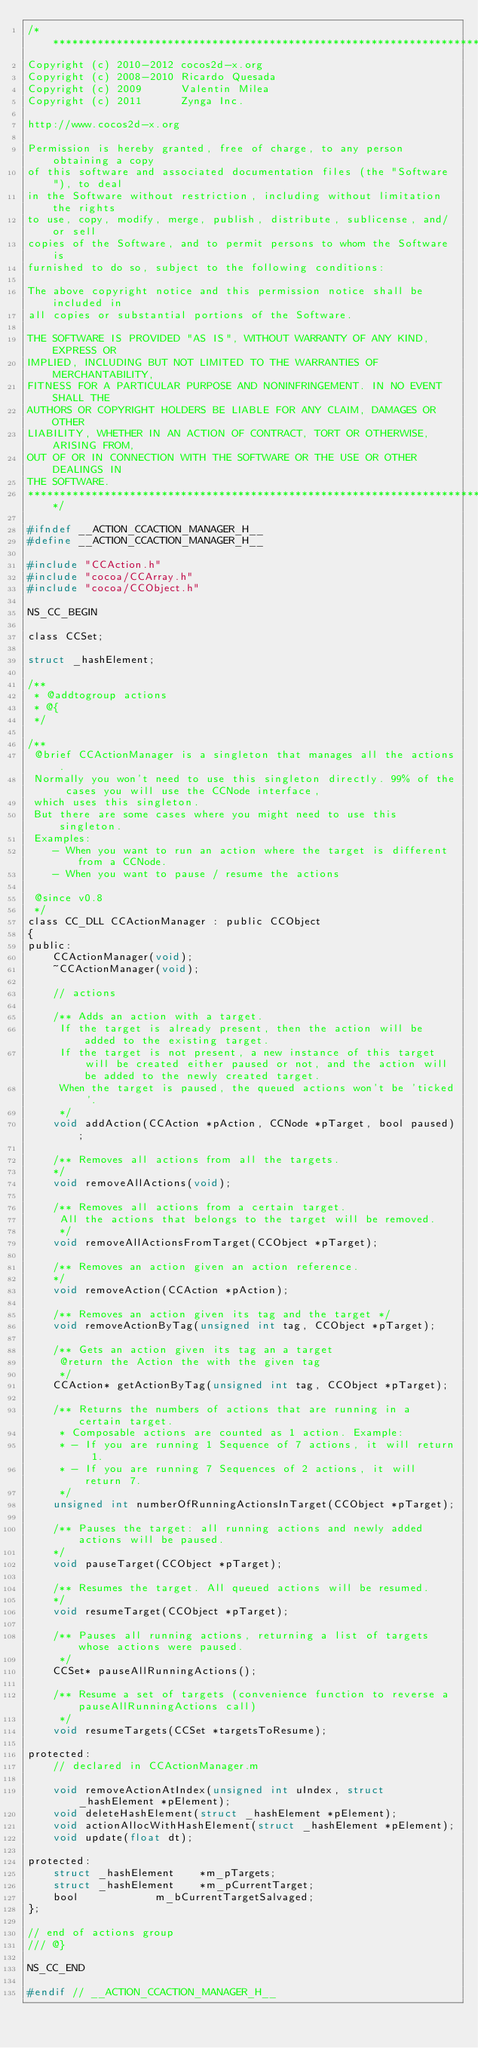Convert code to text. <code><loc_0><loc_0><loc_500><loc_500><_C_>/****************************************************************************
Copyright (c) 2010-2012 cocos2d-x.org
Copyright (c) 2008-2010 Ricardo Quesada
Copyright (c) 2009      Valentin Milea
Copyright (c) 2011      Zynga Inc.

http://www.cocos2d-x.org

Permission is hereby granted, free of charge, to any person obtaining a copy
of this software and associated documentation files (the "Software"), to deal
in the Software without restriction, including without limitation the rights
to use, copy, modify, merge, publish, distribute, sublicense, and/or sell
copies of the Software, and to permit persons to whom the Software is
furnished to do so, subject to the following conditions:

The above copyright notice and this permission notice shall be included in
all copies or substantial portions of the Software.

THE SOFTWARE IS PROVIDED "AS IS", WITHOUT WARRANTY OF ANY KIND, EXPRESS OR
IMPLIED, INCLUDING BUT NOT LIMITED TO THE WARRANTIES OF MERCHANTABILITY,
FITNESS FOR A PARTICULAR PURPOSE AND NONINFRINGEMENT. IN NO EVENT SHALL THE
AUTHORS OR COPYRIGHT HOLDERS BE LIABLE FOR ANY CLAIM, DAMAGES OR OTHER
LIABILITY, WHETHER IN AN ACTION OF CONTRACT, TORT OR OTHERWISE, ARISING FROM,
OUT OF OR IN CONNECTION WITH THE SOFTWARE OR THE USE OR OTHER DEALINGS IN
THE SOFTWARE.
****************************************************************************/

#ifndef __ACTION_CCACTION_MANAGER_H__
#define __ACTION_CCACTION_MANAGER_H__

#include "CCAction.h"
#include "cocoa/CCArray.h"
#include "cocoa/CCObject.h"

NS_CC_BEGIN

class CCSet;

struct _hashElement;

/**
 * @addtogroup actions
 * @{
 */

/** 
 @brief CCActionManager is a singleton that manages all the actions.
 Normally you won't need to use this singleton directly. 99% of the cases you will use the CCNode interface,
 which uses this singleton.
 But there are some cases where you might need to use this singleton.
 Examples:
    - When you want to run an action where the target is different from a CCNode. 
    - When you want to pause / resume the actions
 
 @since v0.8
 */
class CC_DLL CCActionManager : public CCObject
{
public:
    CCActionManager(void);
    ~CCActionManager(void);

    // actions
    
    /** Adds an action with a target. 
     If the target is already present, then the action will be added to the existing target.
     If the target is not present, a new instance of this target will be created either paused or not, and the action will be added to the newly created target.
     When the target is paused, the queued actions won't be 'ticked'.
     */
    void addAction(CCAction *pAction, CCNode *pTarget, bool paused);

    /** Removes all actions from all the targets.
    */
    void removeAllActions(void);

    /** Removes all actions from a certain target.
     All the actions that belongs to the target will be removed.
     */
    void removeAllActionsFromTarget(CCObject *pTarget);

    /** Removes an action given an action reference.
    */
    void removeAction(CCAction *pAction);

    /** Removes an action given its tag and the target */
    void removeActionByTag(unsigned int tag, CCObject *pTarget);

    /** Gets an action given its tag an a target
     @return the Action the with the given tag
     */
    CCAction* getActionByTag(unsigned int tag, CCObject *pTarget);

    /** Returns the numbers of actions that are running in a certain target. 
     * Composable actions are counted as 1 action. Example:
     * - If you are running 1 Sequence of 7 actions, it will return 1.
     * - If you are running 7 Sequences of 2 actions, it will return 7.
     */
    unsigned int numberOfRunningActionsInTarget(CCObject *pTarget);

    /** Pauses the target: all running actions and newly added actions will be paused.
    */
    void pauseTarget(CCObject *pTarget);

    /** Resumes the target. All queued actions will be resumed.
    */
    void resumeTarget(CCObject *pTarget);
    
    /** Pauses all running actions, returning a list of targets whose actions were paused.
     */
    CCSet* pauseAllRunningActions();
    
    /** Resume a set of targets (convenience function to reverse a pauseAllRunningActions call)
     */
    void resumeTargets(CCSet *targetsToResume);

protected:
    // declared in CCActionManager.m

    void removeActionAtIndex(unsigned int uIndex, struct _hashElement *pElement);
    void deleteHashElement(struct _hashElement *pElement);
    void actionAllocWithHashElement(struct _hashElement *pElement);
    void update(float dt);

protected:
    struct _hashElement    *m_pTargets;
    struct _hashElement    *m_pCurrentTarget;
    bool            m_bCurrentTargetSalvaged;
};

// end of actions group
/// @}

NS_CC_END

#endif // __ACTION_CCACTION_MANAGER_H__
</code> 